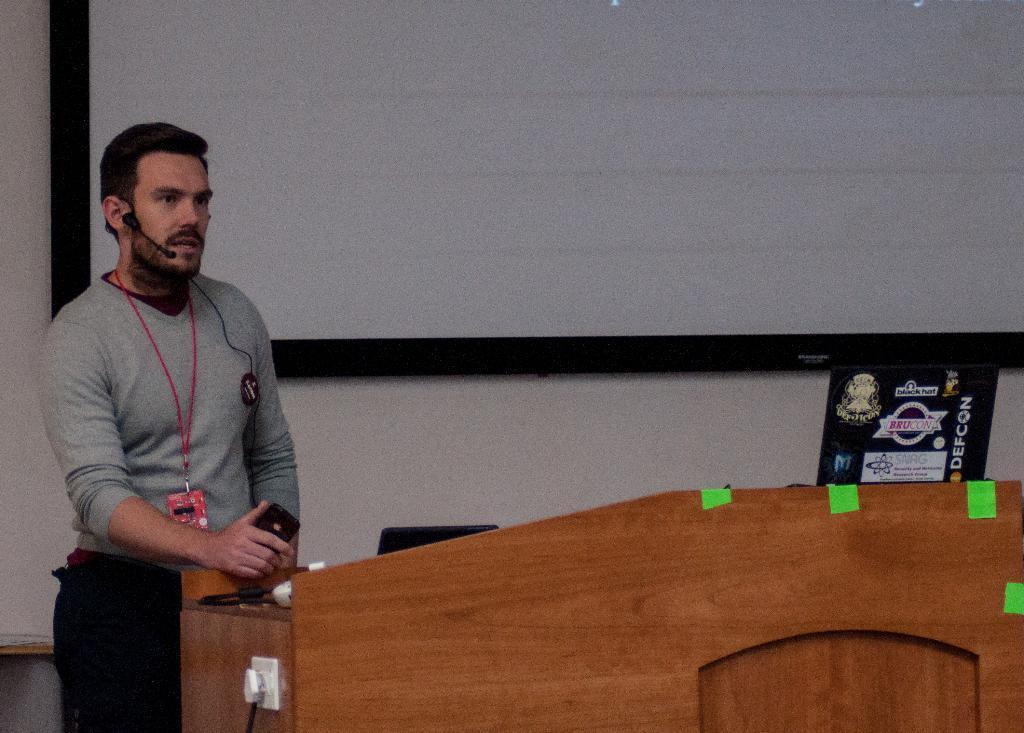Please provide a concise description of this image. In the image on the left side we can see one person standing and he is holding mobile phone. In front of him,we can see one table. On table,we can see black color object,switch board and few other objects. In the background there is a wall and board. 